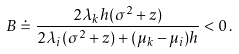Convert formula to latex. <formula><loc_0><loc_0><loc_500><loc_500>B \doteq \frac { 2 \lambda _ { k } h ( \sigma ^ { 2 } + z ) } { 2 \lambda _ { i } ( \sigma ^ { 2 } + z ) + ( \mu _ { k } - \mu _ { i } ) h } < 0 \, .</formula> 